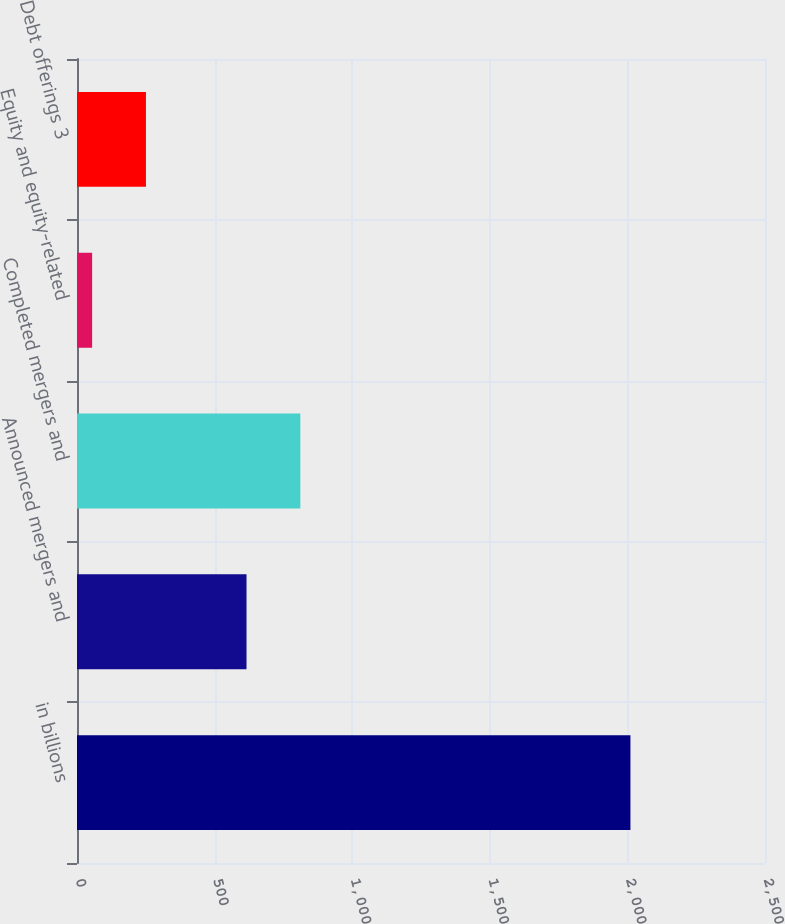<chart> <loc_0><loc_0><loc_500><loc_500><bar_chart><fcel>in billions<fcel>Announced mergers and<fcel>Completed mergers and<fcel>Equity and equity-related<fcel>Debt offerings 3<nl><fcel>2011<fcel>616<fcel>811.6<fcel>55<fcel>250.6<nl></chart> 